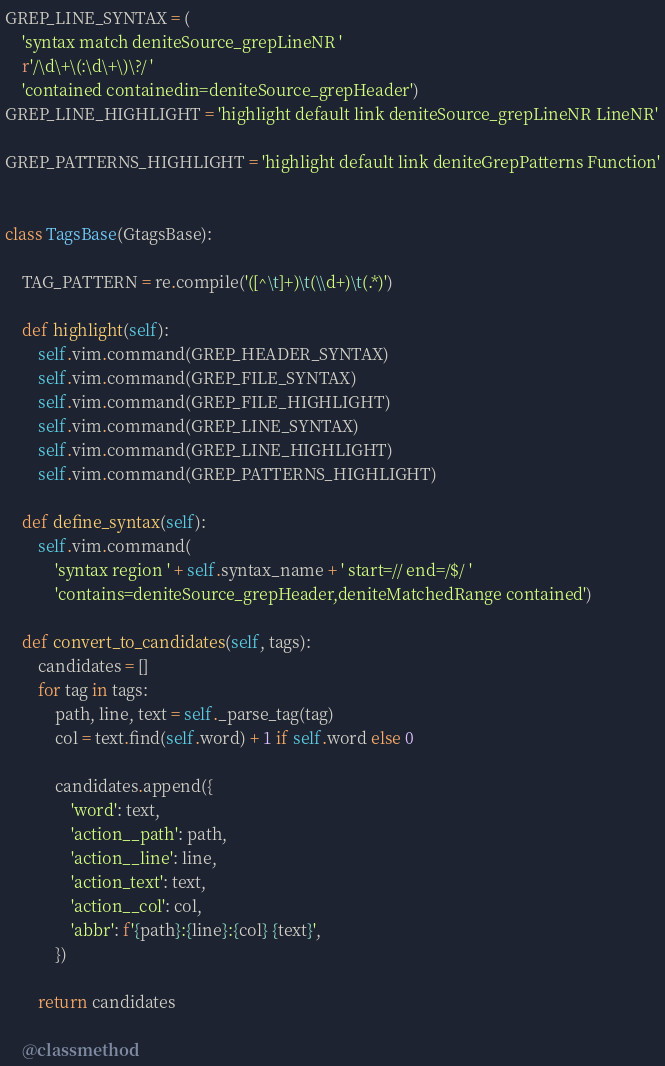Convert code to text. <code><loc_0><loc_0><loc_500><loc_500><_Python_>GREP_LINE_SYNTAX = (
    'syntax match deniteSource_grepLineNR '
    r'/\d\+\(:\d\+\)\?/ '
    'contained containedin=deniteSource_grepHeader')
GREP_LINE_HIGHLIGHT = 'highlight default link deniteSource_grepLineNR LineNR'

GREP_PATTERNS_HIGHLIGHT = 'highlight default link deniteGrepPatterns Function'


class TagsBase(GtagsBase):

    TAG_PATTERN = re.compile('([^\t]+)\t(\\d+)\t(.*)')

    def highlight(self):
        self.vim.command(GREP_HEADER_SYNTAX)
        self.vim.command(GREP_FILE_SYNTAX)
        self.vim.command(GREP_FILE_HIGHLIGHT)
        self.vim.command(GREP_LINE_SYNTAX)
        self.vim.command(GREP_LINE_HIGHLIGHT)
        self.vim.command(GREP_PATTERNS_HIGHLIGHT)

    def define_syntax(self):
        self.vim.command(
            'syntax region ' + self.syntax_name + ' start=// end=/$/ '
            'contains=deniteSource_grepHeader,deniteMatchedRange contained')

    def convert_to_candidates(self, tags):
        candidates = []
        for tag in tags:
            path, line, text = self._parse_tag(tag)
            col = text.find(self.word) + 1 if self.word else 0

            candidates.append({
                'word': text,
                'action__path': path,
                'action__line': line,
                'action_text': text,
                'action__col': col,
                'abbr': f'{path}:{line}:{col} {text}',
            })

        return candidates

    @classmethod</code> 